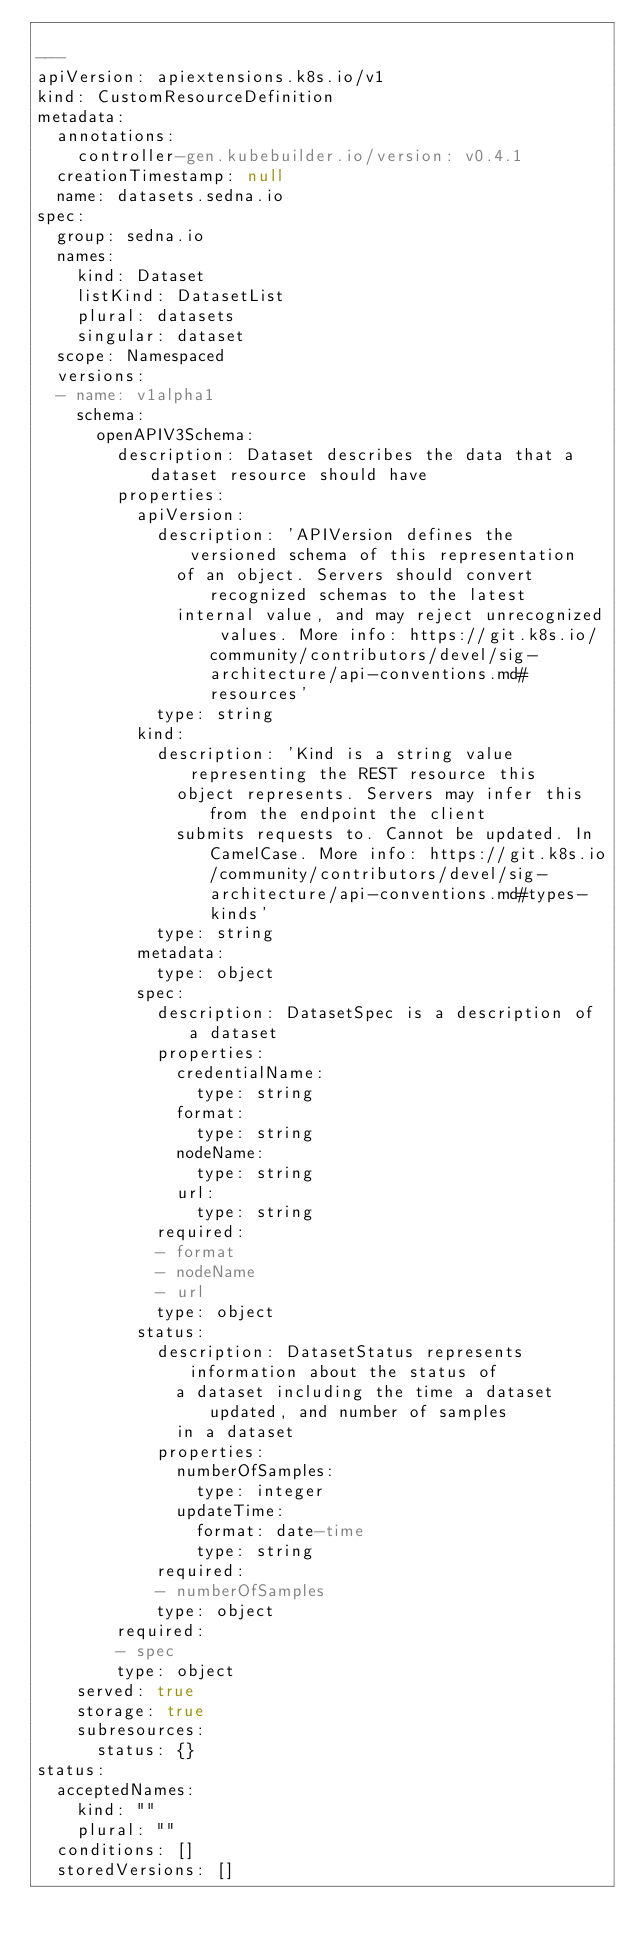Convert code to text. <code><loc_0><loc_0><loc_500><loc_500><_YAML_>
---
apiVersion: apiextensions.k8s.io/v1
kind: CustomResourceDefinition
metadata:
  annotations:
    controller-gen.kubebuilder.io/version: v0.4.1
  creationTimestamp: null
  name: datasets.sedna.io
spec:
  group: sedna.io
  names:
    kind: Dataset
    listKind: DatasetList
    plural: datasets
    singular: dataset
  scope: Namespaced
  versions:
  - name: v1alpha1
    schema:
      openAPIV3Schema:
        description: Dataset describes the data that a dataset resource should have
        properties:
          apiVersion:
            description: 'APIVersion defines the versioned schema of this representation
              of an object. Servers should convert recognized schemas to the latest
              internal value, and may reject unrecognized values. More info: https://git.k8s.io/community/contributors/devel/sig-architecture/api-conventions.md#resources'
            type: string
          kind:
            description: 'Kind is a string value representing the REST resource this
              object represents. Servers may infer this from the endpoint the client
              submits requests to. Cannot be updated. In CamelCase. More info: https://git.k8s.io/community/contributors/devel/sig-architecture/api-conventions.md#types-kinds'
            type: string
          metadata:
            type: object
          spec:
            description: DatasetSpec is a description of a dataset
            properties:
              credentialName:
                type: string
              format:
                type: string
              nodeName:
                type: string
              url:
                type: string
            required:
            - format
            - nodeName
            - url
            type: object
          status:
            description: DatasetStatus represents information about the status of
              a dataset including the time a dataset updated, and number of samples
              in a dataset
            properties:
              numberOfSamples:
                type: integer
              updateTime:
                format: date-time
                type: string
            required:
            - numberOfSamples
            type: object
        required:
        - spec
        type: object
    served: true
    storage: true
    subresources:
      status: {}
status:
  acceptedNames:
    kind: ""
    plural: ""
  conditions: []
  storedVersions: []
</code> 